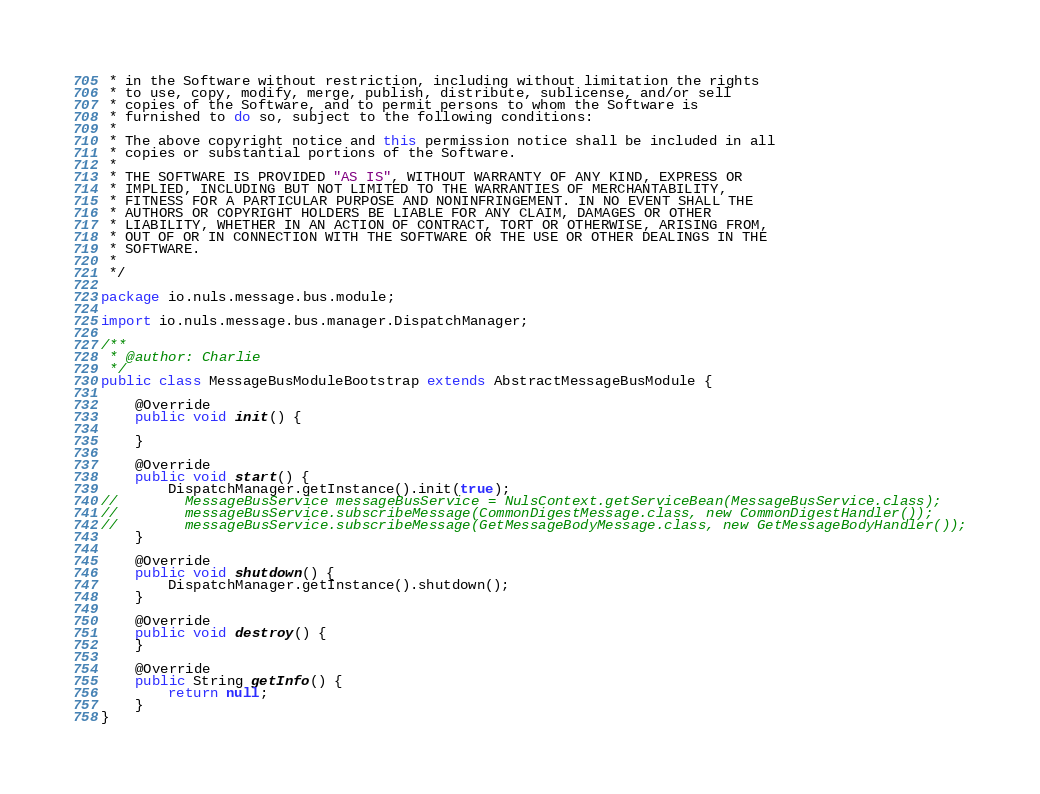<code> <loc_0><loc_0><loc_500><loc_500><_Java_> * in the Software without restriction, including without limitation the rights
 * to use, copy, modify, merge, publish, distribute, sublicense, and/or sell
 * copies of the Software, and to permit persons to whom the Software is
 * furnished to do so, subject to the following conditions:
 *
 * The above copyright notice and this permission notice shall be included in all
 * copies or substantial portions of the Software.
 *
 * THE SOFTWARE IS PROVIDED "AS IS", WITHOUT WARRANTY OF ANY KIND, EXPRESS OR
 * IMPLIED, INCLUDING BUT NOT LIMITED TO THE WARRANTIES OF MERCHANTABILITY,
 * FITNESS FOR A PARTICULAR PURPOSE AND NONINFRINGEMENT. IN NO EVENT SHALL THE
 * AUTHORS OR COPYRIGHT HOLDERS BE LIABLE FOR ANY CLAIM, DAMAGES OR OTHER
 * LIABILITY, WHETHER IN AN ACTION OF CONTRACT, TORT OR OTHERWISE, ARISING FROM,
 * OUT OF OR IN CONNECTION WITH THE SOFTWARE OR THE USE OR OTHER DEALINGS IN THE
 * SOFTWARE.
 *
 */

package io.nuls.message.bus.module;

import io.nuls.message.bus.manager.DispatchManager;

/**
 * @author: Charlie
 */
public class MessageBusModuleBootstrap extends AbstractMessageBusModule {

    @Override
    public void init() {

    }

    @Override
    public void start() {
        DispatchManager.getInstance().init(true);
//        MessageBusService messageBusService = NulsContext.getServiceBean(MessageBusService.class);
//        messageBusService.subscribeMessage(CommonDigestMessage.class, new CommonDigestHandler());
//        messageBusService.subscribeMessage(GetMessageBodyMessage.class, new GetMessageBodyHandler());
    }

    @Override
    public void shutdown() {
        DispatchManager.getInstance().shutdown();
    }

    @Override
    public void destroy() {
    }

    @Override
    public String getInfo() {
        return null;
    }
}
</code> 